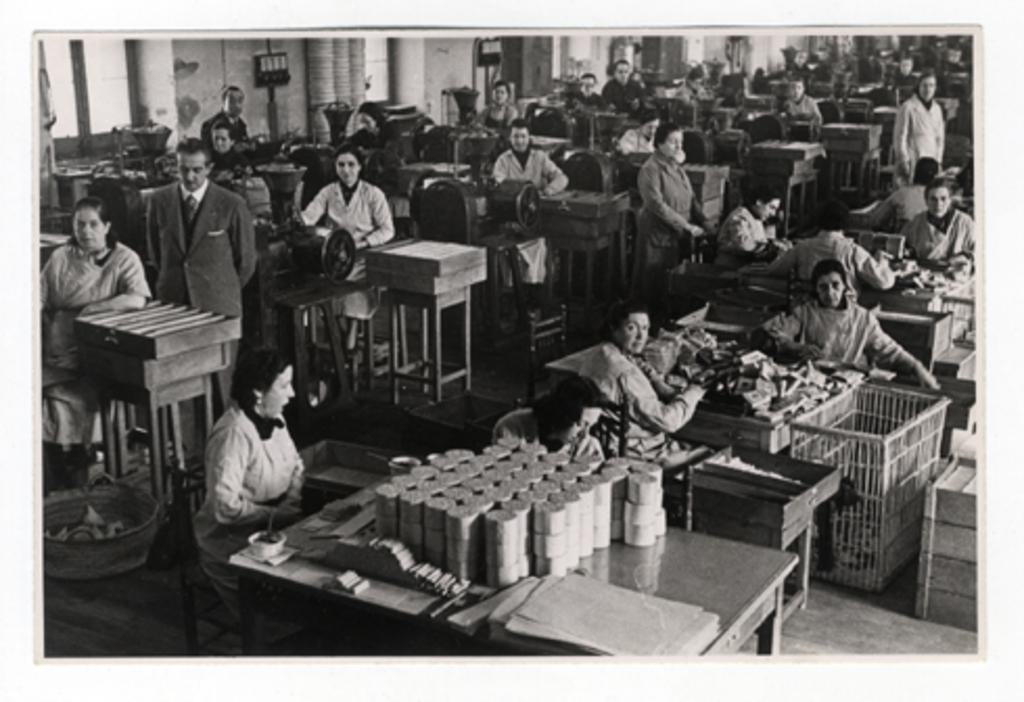What are the people in the image doing? The people in the image are standing and working on machines. Can you describe the woman's position in the image? The woman is seated in the image. What is present on the table in the image? There is some material on a table in the image. What type of wire is the woman using to whistle in the image? There is no wire or whistling activity present in the image. How many rocks can be seen near the machines in the image? There are no rocks visible in the image; it features a group of people working on machines and a seated woman. 